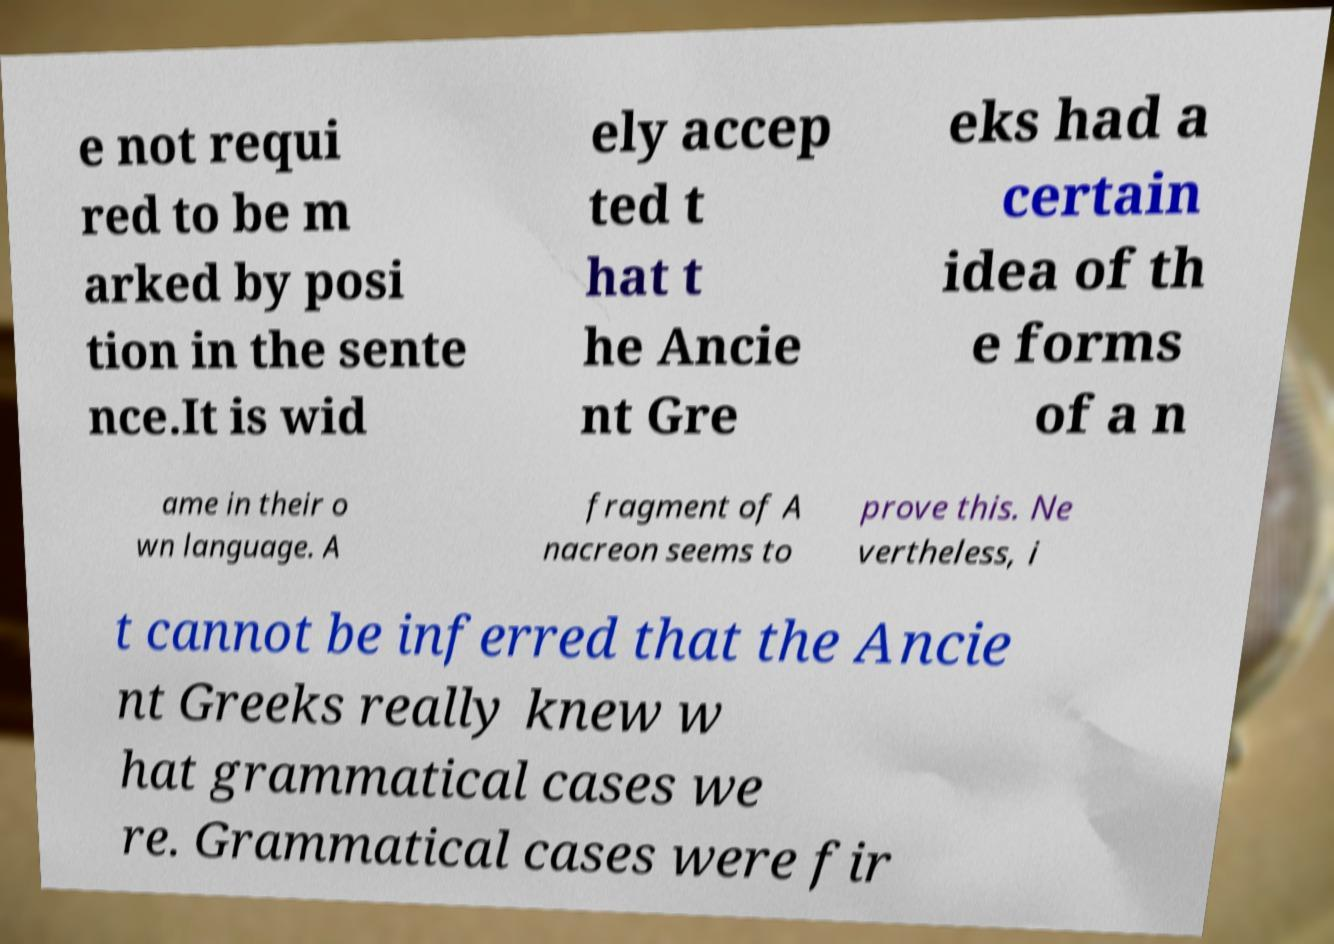Could you extract and type out the text from this image? e not requi red to be m arked by posi tion in the sente nce.It is wid ely accep ted t hat t he Ancie nt Gre eks had a certain idea of th e forms of a n ame in their o wn language. A fragment of A nacreon seems to prove this. Ne vertheless, i t cannot be inferred that the Ancie nt Greeks really knew w hat grammatical cases we re. Grammatical cases were fir 